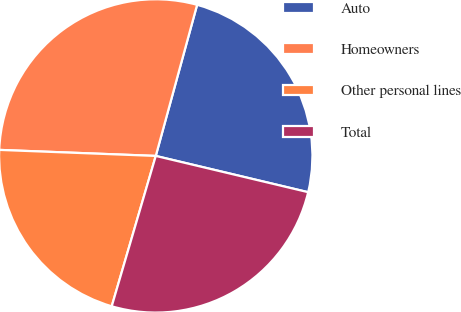Convert chart. <chart><loc_0><loc_0><loc_500><loc_500><pie_chart><fcel>Auto<fcel>Homeowners<fcel>Other personal lines<fcel>Total<nl><fcel>24.47%<fcel>28.64%<fcel>21.08%<fcel>25.82%<nl></chart> 